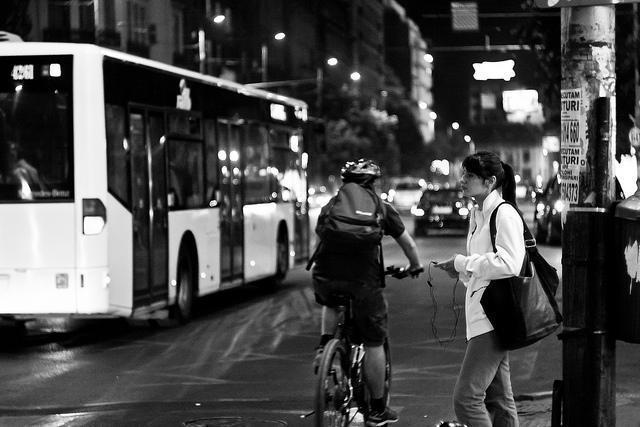What should the bus use to safely move in front of the bicyclist?
From the following four choices, select the correct answer to address the question.
Options: Wiper blades, sign, turning signals, motor. Turning signals. 